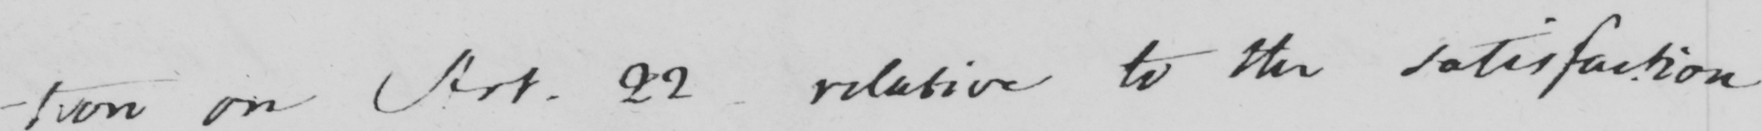Can you read and transcribe this handwriting? -tion on Art . 22 - relative to the satisfaction 